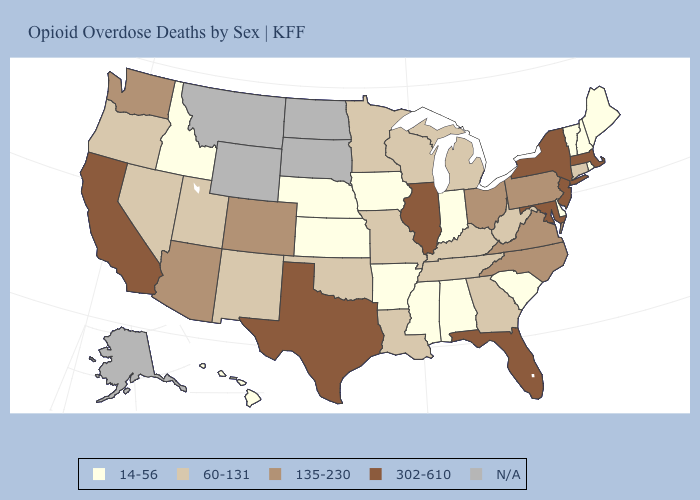Does California have the highest value in the West?
Short answer required. Yes. Name the states that have a value in the range 14-56?
Give a very brief answer. Alabama, Arkansas, Delaware, Hawaii, Idaho, Indiana, Iowa, Kansas, Maine, Mississippi, Nebraska, New Hampshire, Rhode Island, South Carolina, Vermont. Does Mississippi have the highest value in the South?
Write a very short answer. No. How many symbols are there in the legend?
Quick response, please. 5. Name the states that have a value in the range N/A?
Quick response, please. Alaska, Montana, North Dakota, South Dakota, Wyoming. What is the value of Iowa?
Give a very brief answer. 14-56. What is the value of Mississippi?
Short answer required. 14-56. What is the lowest value in states that border Washington?
Be succinct. 14-56. What is the value of Delaware?
Give a very brief answer. 14-56. Name the states that have a value in the range 302-610?
Write a very short answer. California, Florida, Illinois, Maryland, Massachusetts, New Jersey, New York, Texas. Name the states that have a value in the range 60-131?
Be succinct. Connecticut, Georgia, Kentucky, Louisiana, Michigan, Minnesota, Missouri, Nevada, New Mexico, Oklahoma, Oregon, Tennessee, Utah, West Virginia, Wisconsin. What is the highest value in the USA?
Answer briefly. 302-610. Among the states that border California , which have the highest value?
Be succinct. Arizona. 